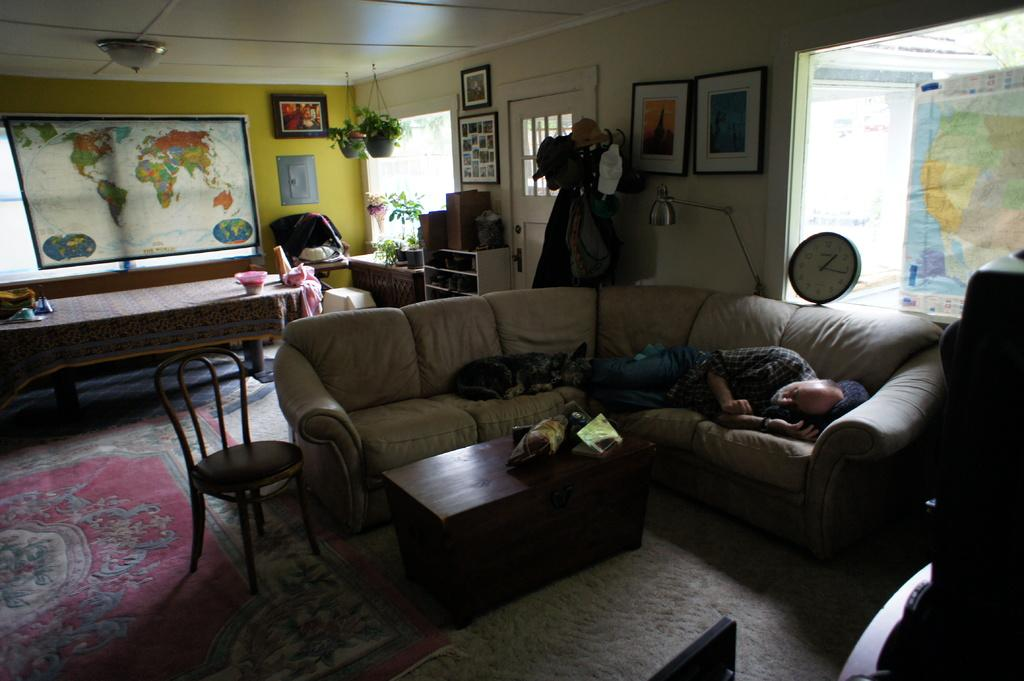Who is present in the image? There is an old man in the image. What is the old man doing? The old man is sleeping. Is there any other living being in the image? Yes, there is a dog in the image. What is the dog doing? The dog is sleeping. Where are the old man and the dog located? They are on a sofa. What type of room is depicted in the image? The setting is a living room. How many sheep can be seen in the image? There are no sheep present in the image. Is the fan visible in the image? There is no fan mentioned or visible in the image. 